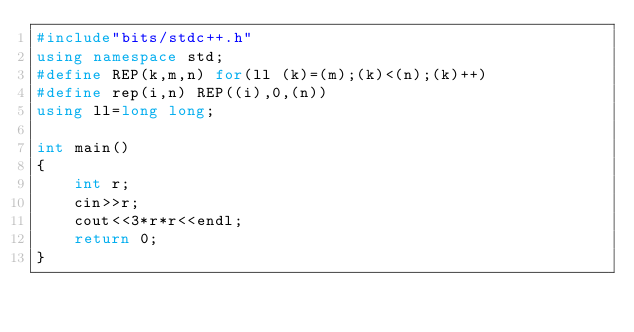Convert code to text. <code><loc_0><loc_0><loc_500><loc_500><_C++_>#include"bits/stdc++.h"
using namespace std;
#define REP(k,m,n) for(ll (k)=(m);(k)<(n);(k)++)
#define rep(i,n) REP((i),0,(n))
using ll=long long;

int main()
{
	int r;
	cin>>r;
	cout<<3*r*r<<endl;
	return 0;
}
</code> 